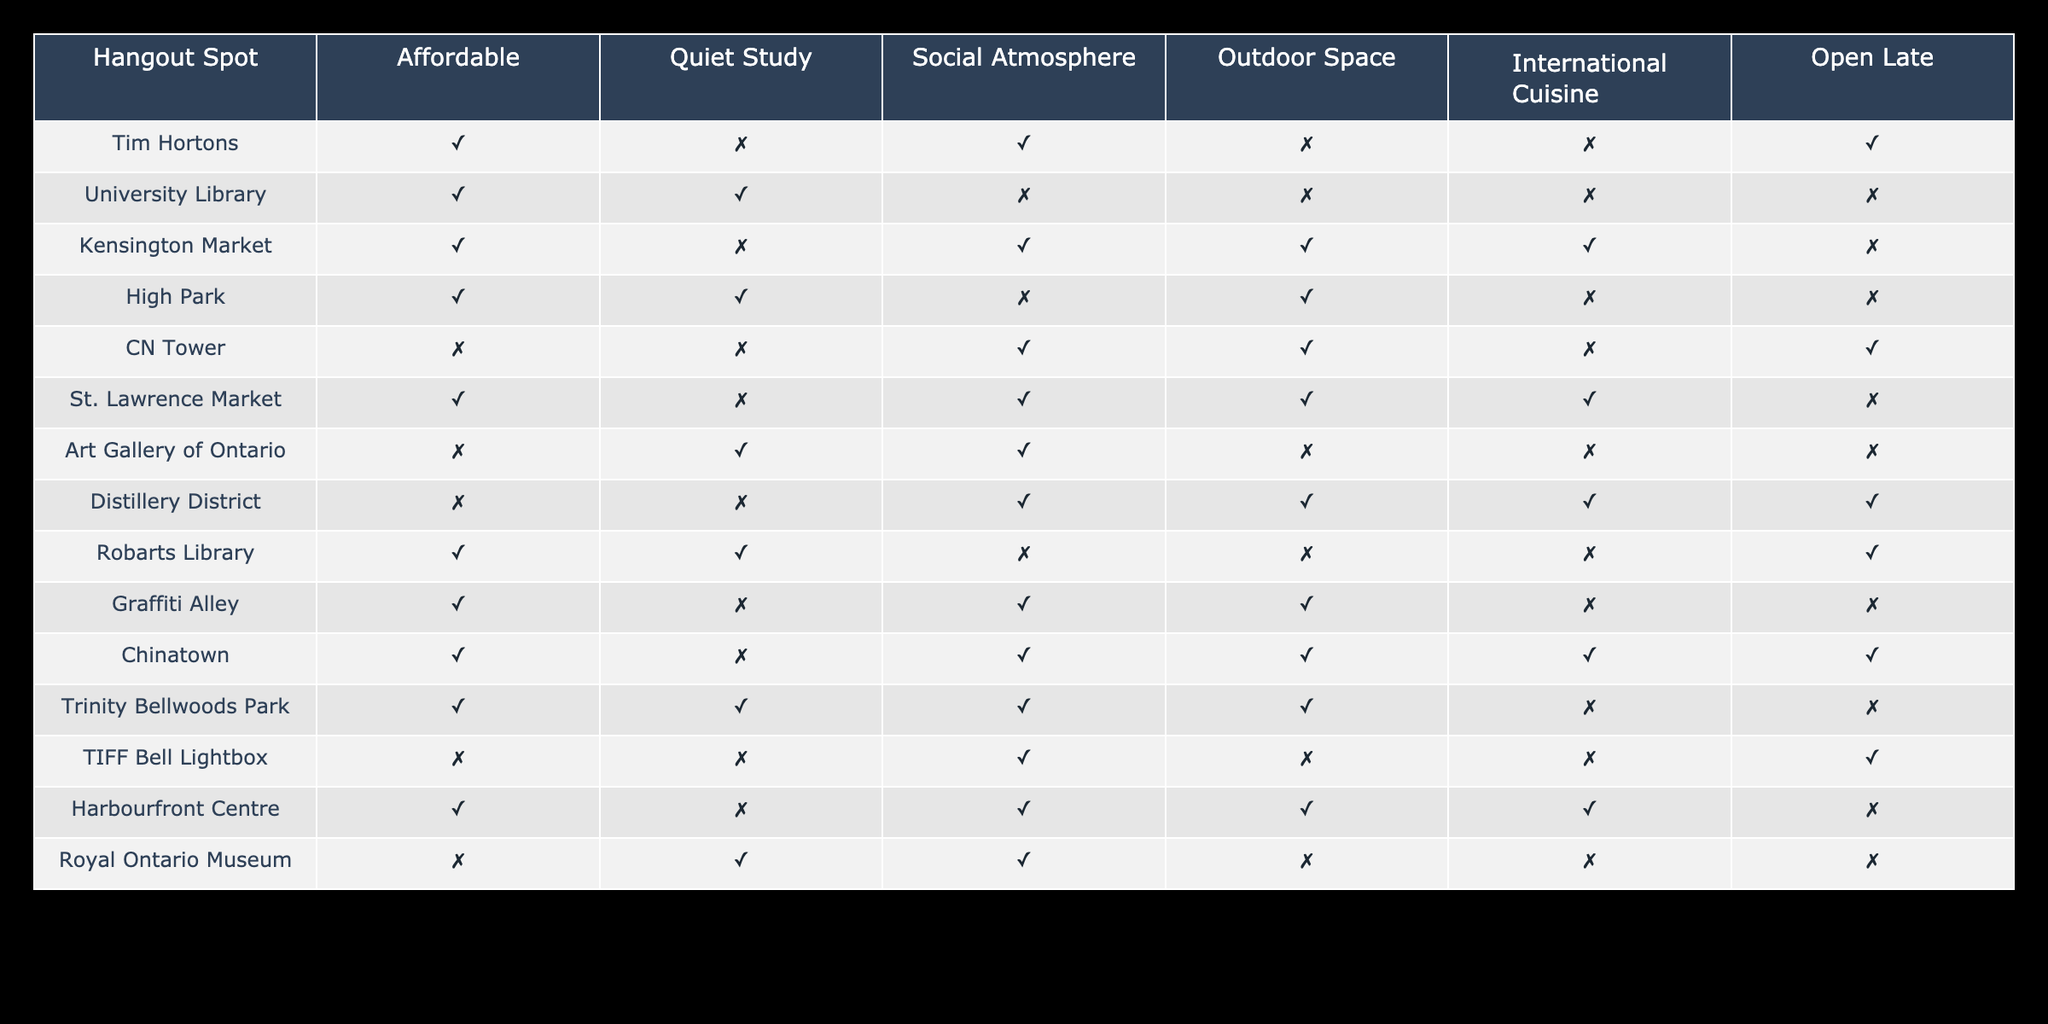What are some hangout spots that are open late? From the table, I can look down the "Open Late" column. The spots with "TRUE" in this column are Tim Hortons, CN Tower, Distillery District, Robarts Library, TIFF Bell Lightbox, and Harbourfront Centre.
Answer: Tim Hortons, CN Tower, Distillery District, Robarts Library, TIFF Bell Lightbox, Harbourfront Centre Which hangout spot has both a quiet study environment and an outdoor space? I need to check both the "Quiet Study" and "Outdoor Space" columns. The records showing "TRUE" for both are: High Park and Trinity Bellwoods Park.
Answer: High Park, Trinity Bellwoods Park Is St. Lawrence Market affordable? Looking at the "Affordable" column, St. Lawrence Market shows "TRUE," indicating that it is affordable.
Answer: Yes How many hangout spots offer international cuisine? I will look at the "International Cuisine" column and count the instances of "TRUE". The spots that provide international cuisine are Kensington Market, St. Lawrence Market, Chinatown, and Harbourfront Centre. That totals four spots.
Answer: 4 Which hangout space is social and has an outdoor area but is not quiet for studying? I first check the "Social Atmosphere" column for "TRUE" and the "Outdoor Space" for "TRUE" while ensuring "Quiet Study" is "FALSE." The only match is the Distillery District.
Answer: Distillery District Are any spots both affordable and have a social atmosphere? I will review the "Affordable" and "Social Atmosphere" columns. The spots that have "TRUE" for both are Tim Hortons, Kensington Market, St. Lawrence Market, Chinatown, and Trinity Bellwoods Park.
Answer: Tim Hortons, Kensington Market, St. Lawrence Market, Chinatown, Trinity Bellwoods Park What is the total number of spots that are suitable for outdoor activities? I count the "Outdoor Space" column for each "TRUE". The matches are Kensington Market, High Park, CN Tower, Distillery District, Graffiti Alley, Chinatown, and Trinity Bellwoods Park. This gives a total of seven spots.
Answer: 7 Is the Royal Ontario Museum social? Checking the "Social Atmosphere" column for the Royal Ontario Museum shows "TRUE." Therefore, it is considered social.
Answer: Yes Which hangout space has a combination of quiet study and social atmosphere but does not offer international cuisine? I need to find a spot where "Quiet Study" is "TRUE," "Social Atmosphere" is "TRUE," and "International Cuisine" is "FALSE." The only spot that fits this criterion is the Trinity Bellwoods Park.
Answer: Trinity Bellwoods Park 